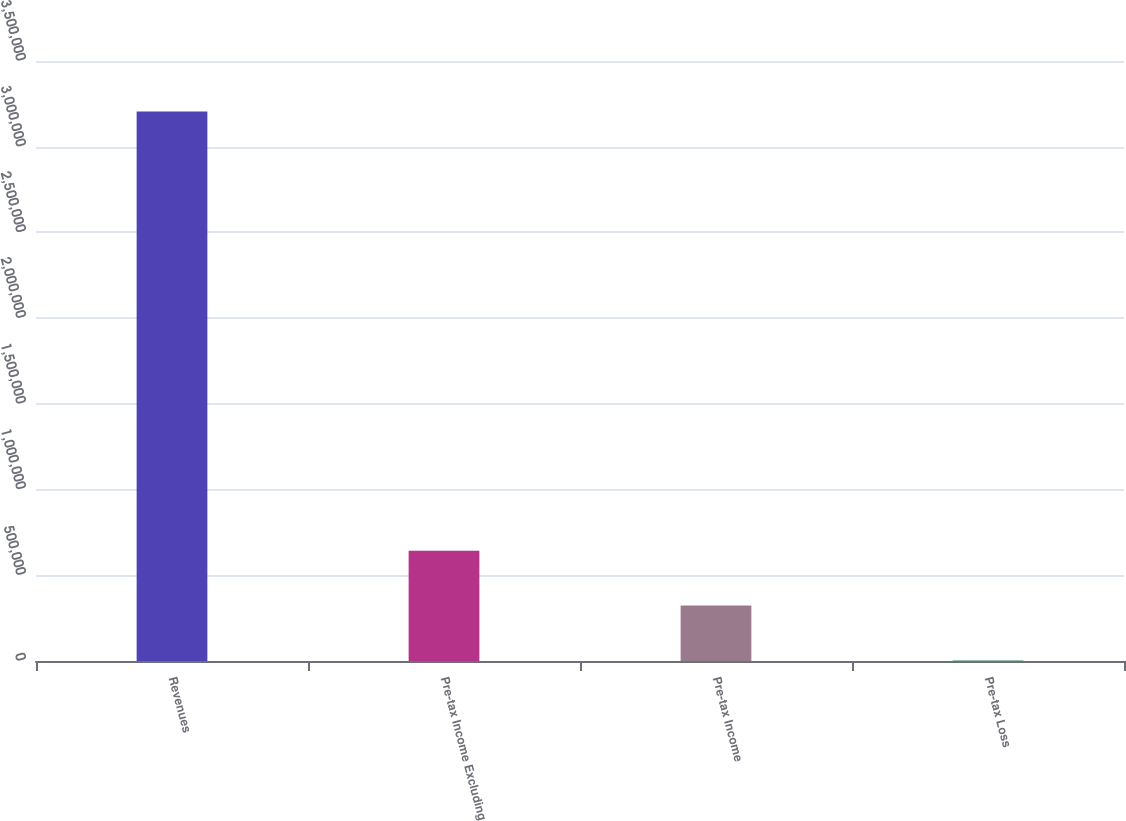Convert chart. <chart><loc_0><loc_0><loc_500><loc_500><bar_chart><fcel>Revenues<fcel>Pre-tax Income Excluding<fcel>Pre-tax Income<fcel>Pre-tax Loss<nl><fcel>3.20493e+06<fcel>643727<fcel>323577<fcel>3426<nl></chart> 